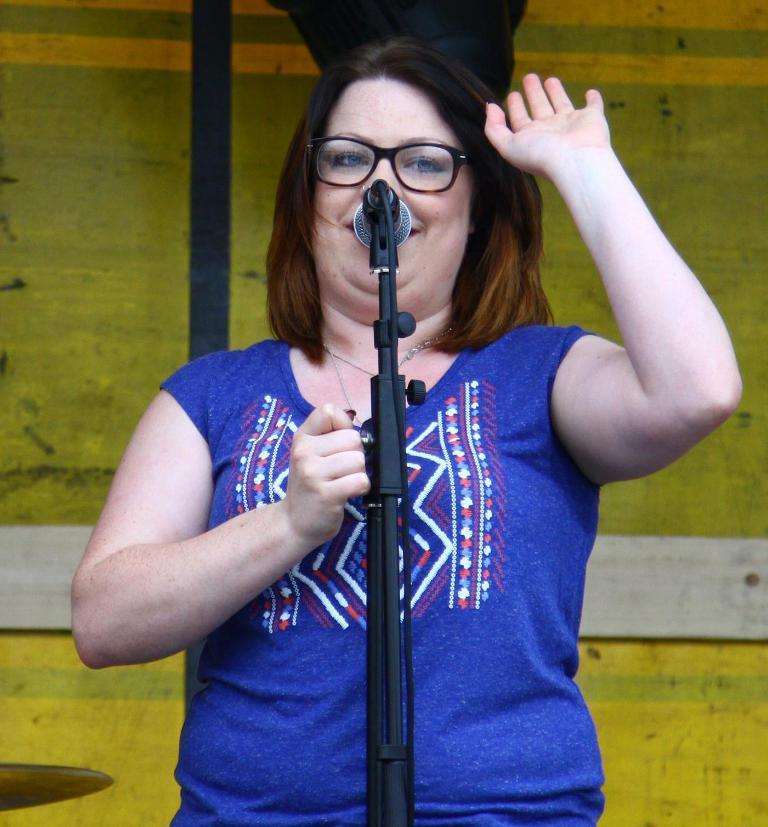In one or two sentences, can you explain what this image depicts? In this picture I can observe a woman standing in front of a mic. She is wearing blue color T shirt and spectacles. Woman is smiling. 